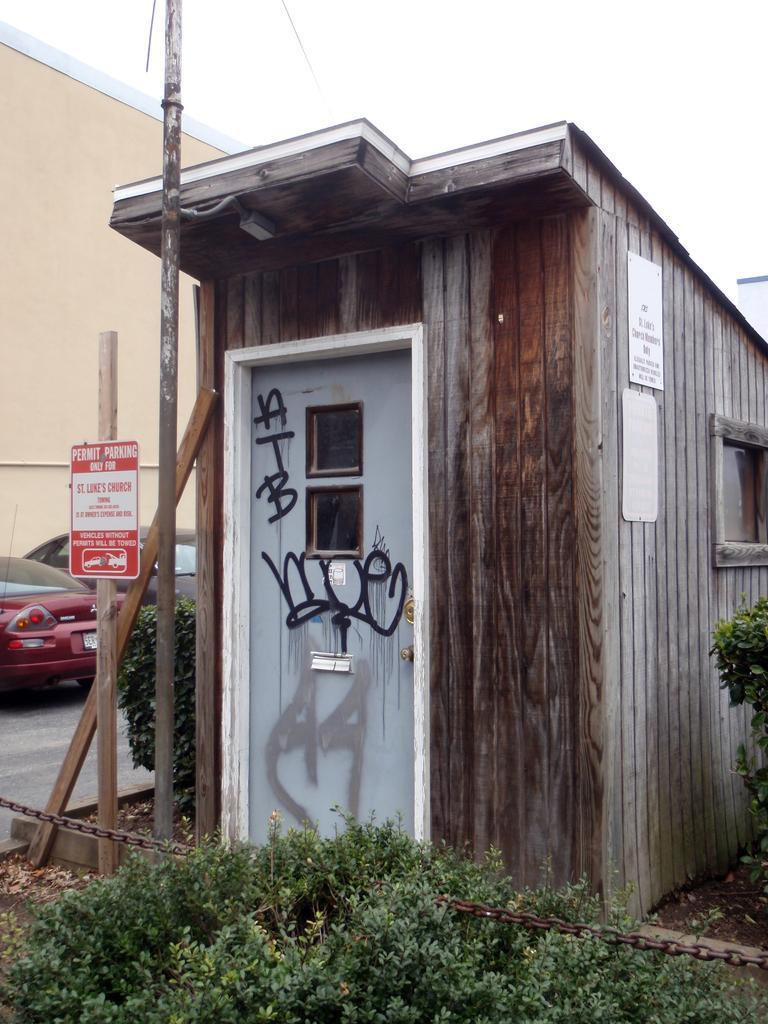Could you give a brief overview of what you see in this image? This picture is clicked outside. In the foreground we can see the plants and a cabin, we can see the text on the board which is attached to the wooden pole. In the background we can see the sky, buildings, cars parked on the ground, and we can see the text on the door of the cabin. 